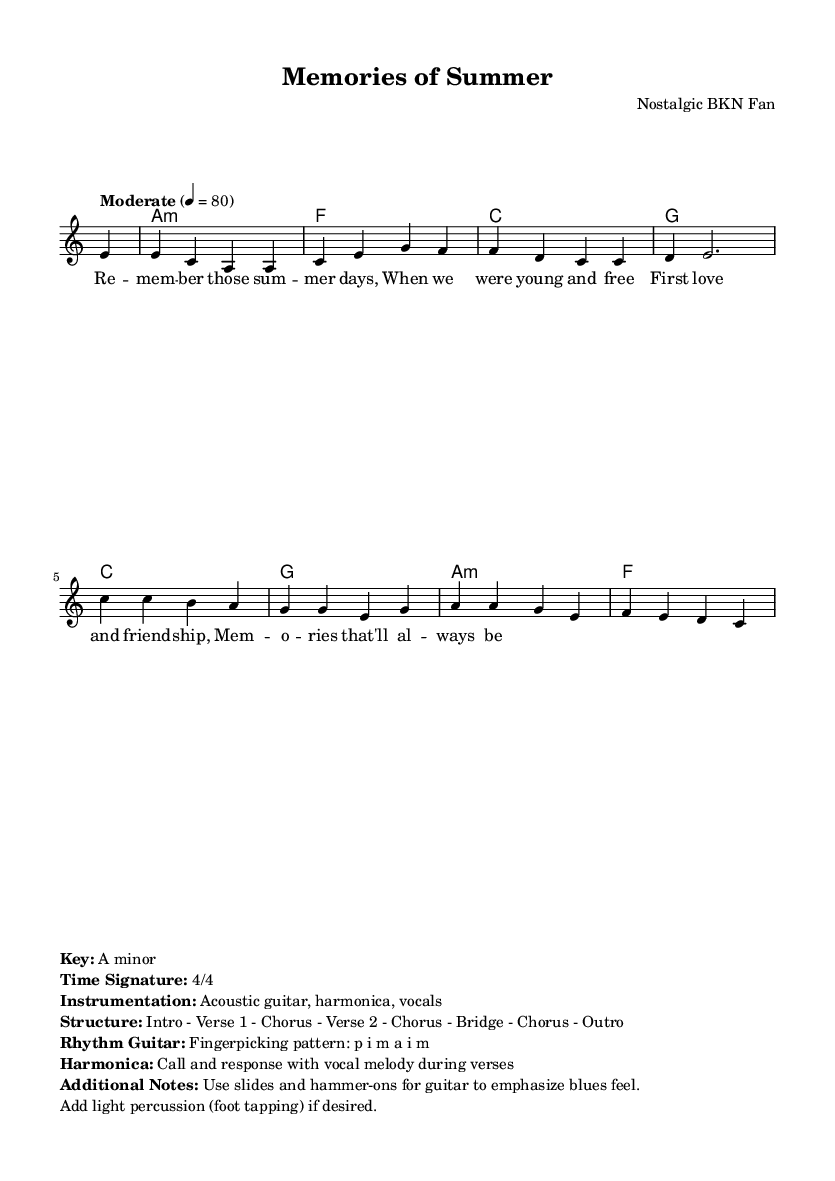What is the key signature of this music? The key signature is A minor, which has no sharps or flats, indicated at the beginning of the score.
Answer: A minor What is the time signature of this music? The time signature is 4/4, which is mentioned at the beginning of the score and indicates there are four beats in each measure.
Answer: 4/4 What is the tempo of this piece? The tempo is marked as "Moderate" with a metronome marking of 80 beats per minute, indicating how fast the music should be played.
Answer: 80 How many verses are in the structure of the music? The structure includes two verses, as indicated in the layout section that outlines the song's components.
Answer: 2 What is the main theme of the lyrics? The main theme revolves around nostalgia, friendship, and first love, as reflected in the lyrics of the verses and chorus.
Answer: Nostalgia What instrumentation is used in this piece? The instrumentation includes acoustic guitar, harmonica, and vocals, which is listed in the notes section of the score.
Answer: Acoustic guitar, harmonica, vocals What fingerpicking pattern is suggested for the rhythm guitar? The fingerpicking pattern suggested is p i m a i m, which is noted in the additional information provided in the score.
Answer: p i m a i m 